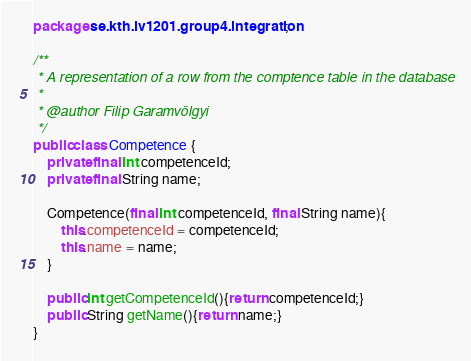Convert code to text. <code><loc_0><loc_0><loc_500><loc_500><_Java_>package se.kth.iv1201.group4.integration;

/**
 * A representation of a row from the comptence table in the database
 *
 * @author Filip Garamvölgyi
 */
public class Competence {
    private final int competenceId;
    private final String name;

    Competence(final int competenceId, final String name){
        this.competenceId = competenceId;
        this.name = name;
    }

    public int getCompetenceId(){return competenceId;}
    public String getName(){return name;}
}
</code> 